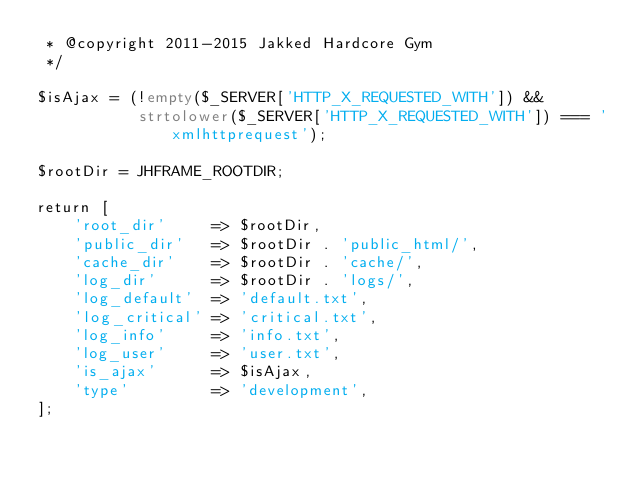Convert code to text. <code><loc_0><loc_0><loc_500><loc_500><_PHP_> * @copyright 2011-2015 Jakked Hardcore Gym
 */

$isAjax = (!empty($_SERVER['HTTP_X_REQUESTED_WITH']) &&
           strtolower($_SERVER['HTTP_X_REQUESTED_WITH']) === 'xmlhttprequest');

$rootDir = JHFRAME_ROOTDIR;

return [
    'root_dir'     => $rootDir,
    'public_dir'   => $rootDir . 'public_html/',
    'cache_dir'    => $rootDir . 'cache/',
    'log_dir'      => $rootDir . 'logs/',
    'log_default'  => 'default.txt',
    'log_critical' => 'critical.txt',
    'log_info'     => 'info.txt',
    'log_user'     => 'user.txt',
    'is_ajax'      => $isAjax,
    'type'         => 'development',
];
</code> 